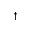Convert formula to latex. <formula><loc_0><loc_0><loc_500><loc_500>^ { \dag }</formula> 